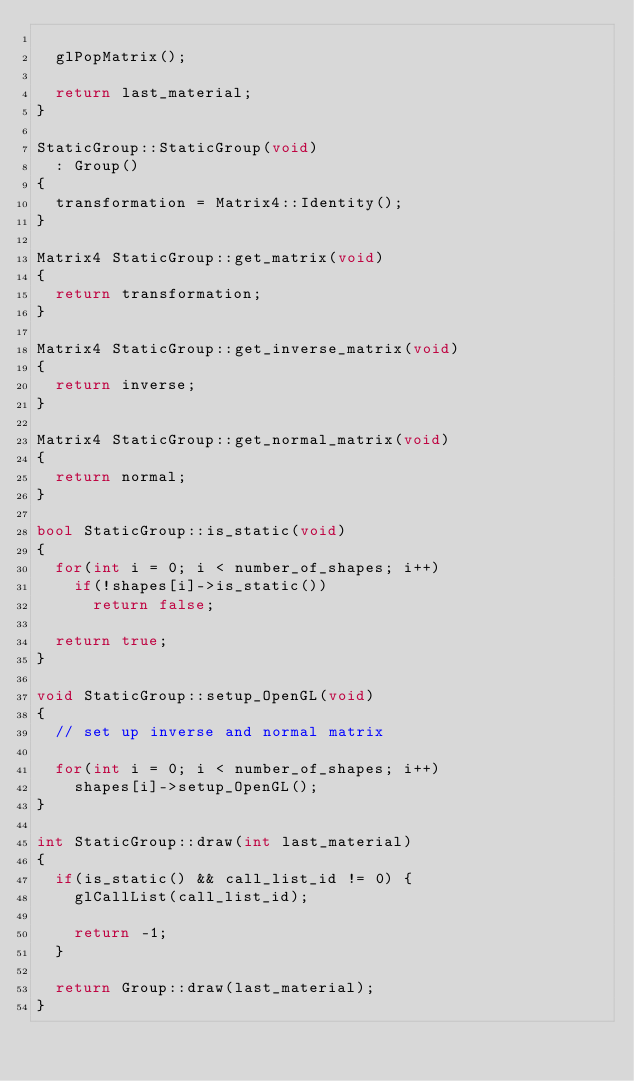<code> <loc_0><loc_0><loc_500><loc_500><_C++_>
  glPopMatrix();

  return last_material;
}

StaticGroup::StaticGroup(void)
  : Group()
{
  transformation = Matrix4::Identity();
}

Matrix4 StaticGroup::get_matrix(void)
{
  return transformation;
}

Matrix4 StaticGroup::get_inverse_matrix(void)
{
  return inverse;
}

Matrix4 StaticGroup::get_normal_matrix(void)
{
  return normal;
}

bool StaticGroup::is_static(void)
{
  for(int i = 0; i < number_of_shapes; i++)
    if(!shapes[i]->is_static())
      return false;

  return true;
}

void StaticGroup::setup_OpenGL(void)
{
  // set up inverse and normal matrix

  for(int i = 0; i < number_of_shapes; i++)
    shapes[i]->setup_OpenGL();
}

int StaticGroup::draw(int last_material)
{
  if(is_static() && call_list_id != 0) {
    glCallList(call_list_id);

    return -1;
  }

  return Group::draw(last_material);
}

</code> 